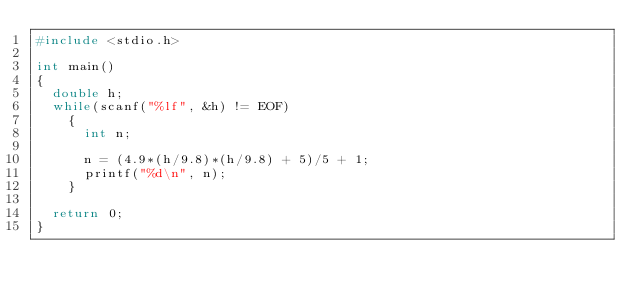Convert code to text. <code><loc_0><loc_0><loc_500><loc_500><_C_>#include <stdio.h>

int main()
{
  double h;
  while(scanf("%lf", &h) != EOF)
    {
      int n;
      
      n = (4.9*(h/9.8)*(h/9.8) + 5)/5 + 1;
      printf("%d\n", n);
    }

  return 0;
}
	  </code> 